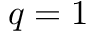<formula> <loc_0><loc_0><loc_500><loc_500>q = 1</formula> 